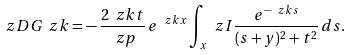Convert formula to latex. <formula><loc_0><loc_0><loc_500><loc_500>\ z D G _ { \ } z k = - \, \frac { 2 \ z k t } { \ z p } \, e ^ { \ z k x } \int _ { x } ^ { \ } z I \frac { e ^ { - \ z k s } } { ( s + y ) ^ { 2 } + t ^ { 2 } } \, d s .</formula> 